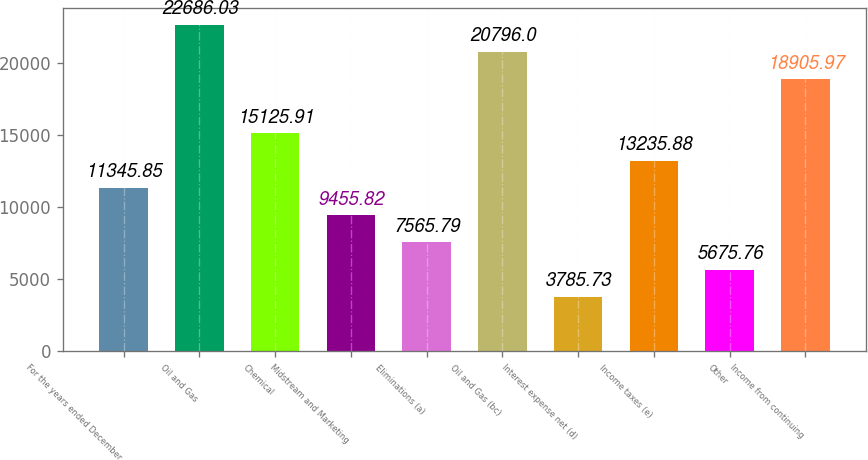Convert chart to OTSL. <chart><loc_0><loc_0><loc_500><loc_500><bar_chart><fcel>For the years ended December<fcel>Oil and Gas<fcel>Chemical<fcel>Midstream and Marketing<fcel>Eliminations (a)<fcel>Oil and Gas (bc)<fcel>Interest expense net (d)<fcel>Income taxes (e)<fcel>Other<fcel>Income from continuing<nl><fcel>11345.9<fcel>22686<fcel>15125.9<fcel>9455.82<fcel>7565.79<fcel>20796<fcel>3785.73<fcel>13235.9<fcel>5675.76<fcel>18906<nl></chart> 